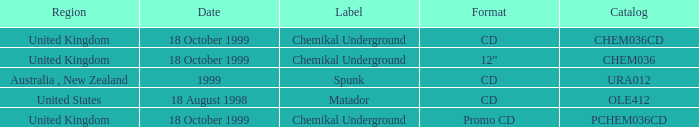What label is associated with the United Kingdom and the chem036 catalog? Chemikal Underground. 